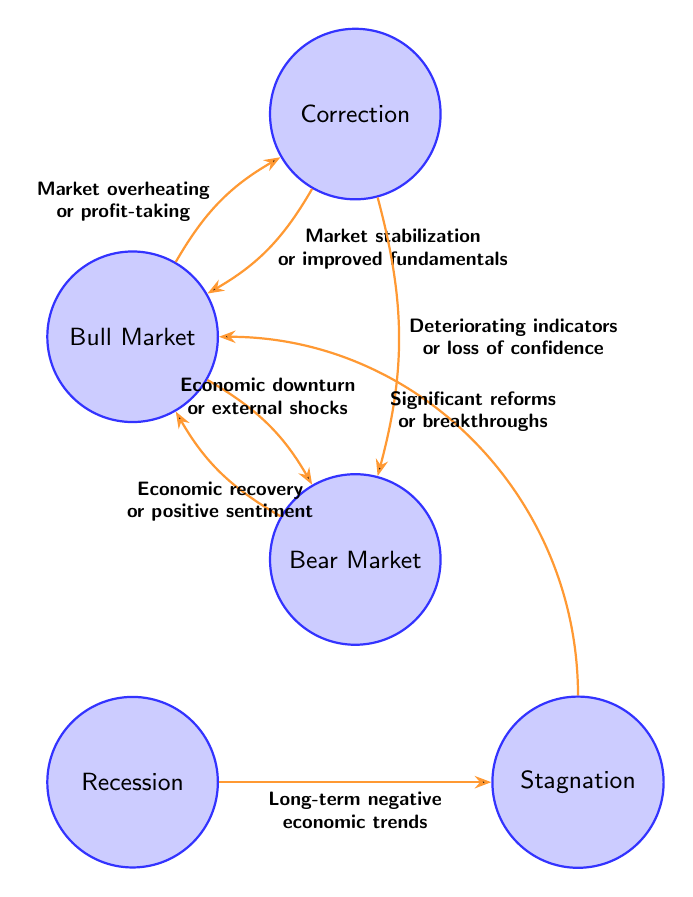What is the starting state in the diagram? The starting state is typically recognized as the Bull Market because it is positioned at the top and has transitions leading to other states.
Answer: Bull Market How many total states are presented in the diagram? To find the total number of states, we count each unique state represented in the diagram. There are five states: Bull Market, Bear Market, Correction, Recession, and Stagnation.
Answer: 5 What triggers the transition from Bear Market to Bull Market? The transition from Bear Market to Bull Market is triggered by economic recovery or positive market sentiment, as indicated on the arrow connecting these two states within the diagram.
Answer: Economic recovery or positive market sentiment What happens when the market experiences overheating or profit-taking? When the market experiences overheating or profit-taking, it transitions from the Bull Market to the Correction state, as indicated by the specific transition labeled on the diagram.
Answer: Correction If the market is in a Correction state, what could lead to a transition back to the Bull Market? Transitioning from the Correction state back to the Bull Market occurs due to market stabilization or improved fundamentals, which is clearly indicated as the trigger in the diagram.
Answer: Market stabilization or improved fundamentals Which state leads to Stagnation if the market is in a recession? When the market is in a Recession, the only transition indicated is to Stagnation, which follows the path labeled with long-term negative economic trends as the trigger for the transition.
Answer: Stagnation How many distinct transitions connect the states in the diagram? To answer this, we can count the connections (transitions) between states. There are a total of seven distinct transitions shown in the diagram, linking the different states together.
Answer: 7 What is the trigger for moving from Correction to Bear Market? The transition from Correction to Bear Market occurs when there is a deterioration in economic indicators or a loss of investor confidence, as noted on the transition between these states.
Answer: Deteriorating economic indicators or loss of investor confidence What significant change can lead to a transition from Stagnation to Bull Market? The transition from Stagnation back to Bull Market is prompted by significant economic reforms or breakthroughs, clearly specified as a trigger in the diagram connecting these states.
Answer: Significant economic reforms or breakthroughs 